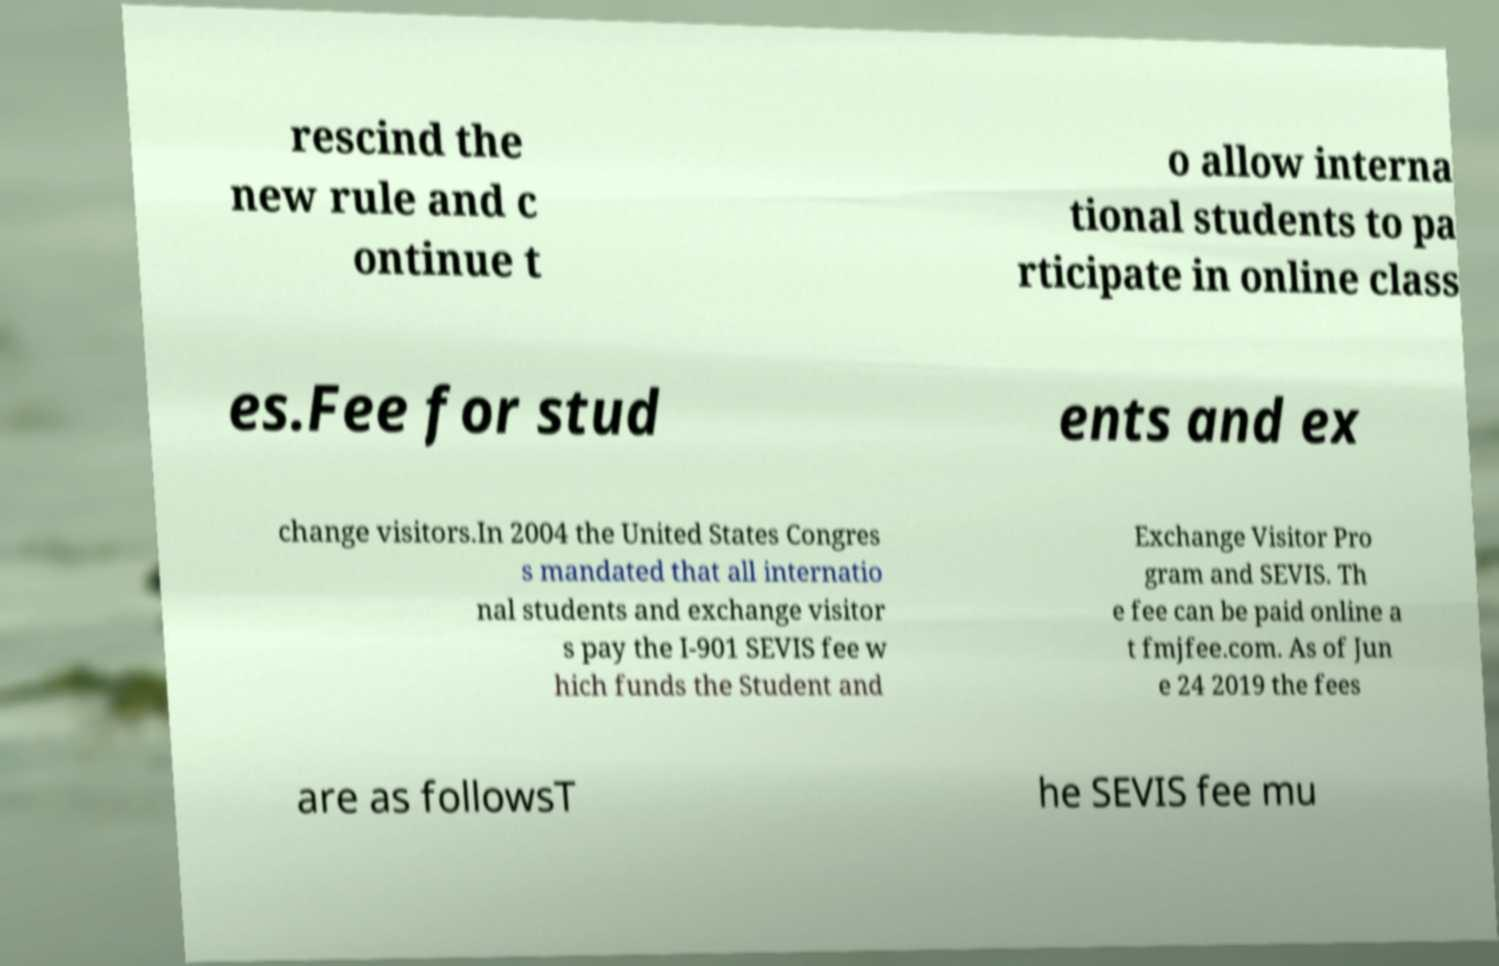Could you assist in decoding the text presented in this image and type it out clearly? rescind the new rule and c ontinue t o allow interna tional students to pa rticipate in online class es.Fee for stud ents and ex change visitors.In 2004 the United States Congres s mandated that all internatio nal students and exchange visitor s pay the I-901 SEVIS fee w hich funds the Student and Exchange Visitor Pro gram and SEVIS. Th e fee can be paid online a t fmjfee.com. As of Jun e 24 2019 the fees are as followsT he SEVIS fee mu 